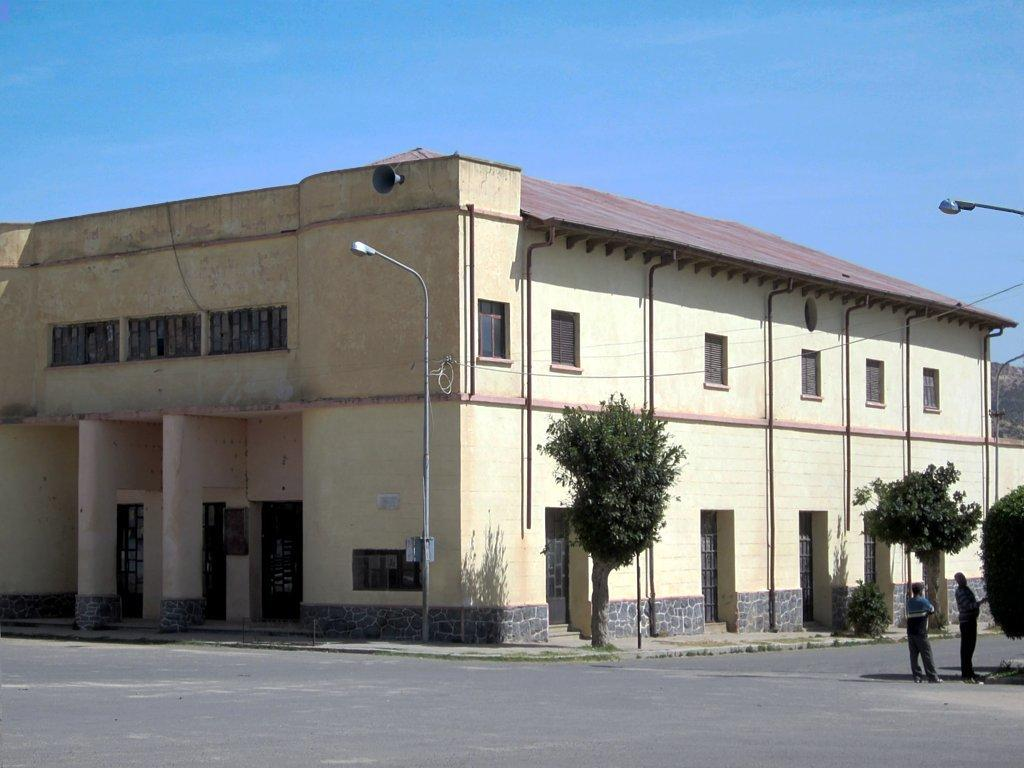What type of structure is visible in the image? There is a building with windows in the image. What is on top of the building? The building has a roof. What can be seen in the background of the image? There are trees visible in the image. What are the street poles used for? Street poles are present in the image, likely for supporting streetlights or other infrastructure. How many people are in the image? There are two people standing on the ground in the image. What else can be seen in the image? Some wires are visible in the image, and the sky is visible as well. What type of coil is being used by the people in the image? There is no coil present in the image; the people are simply standing on the ground. What idea is being discussed by the people in the image? The image does not provide any information about what the people might be discussing or thinking. 